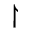<formula> <loc_0><loc_0><loc_500><loc_500>\upharpoonright</formula> 